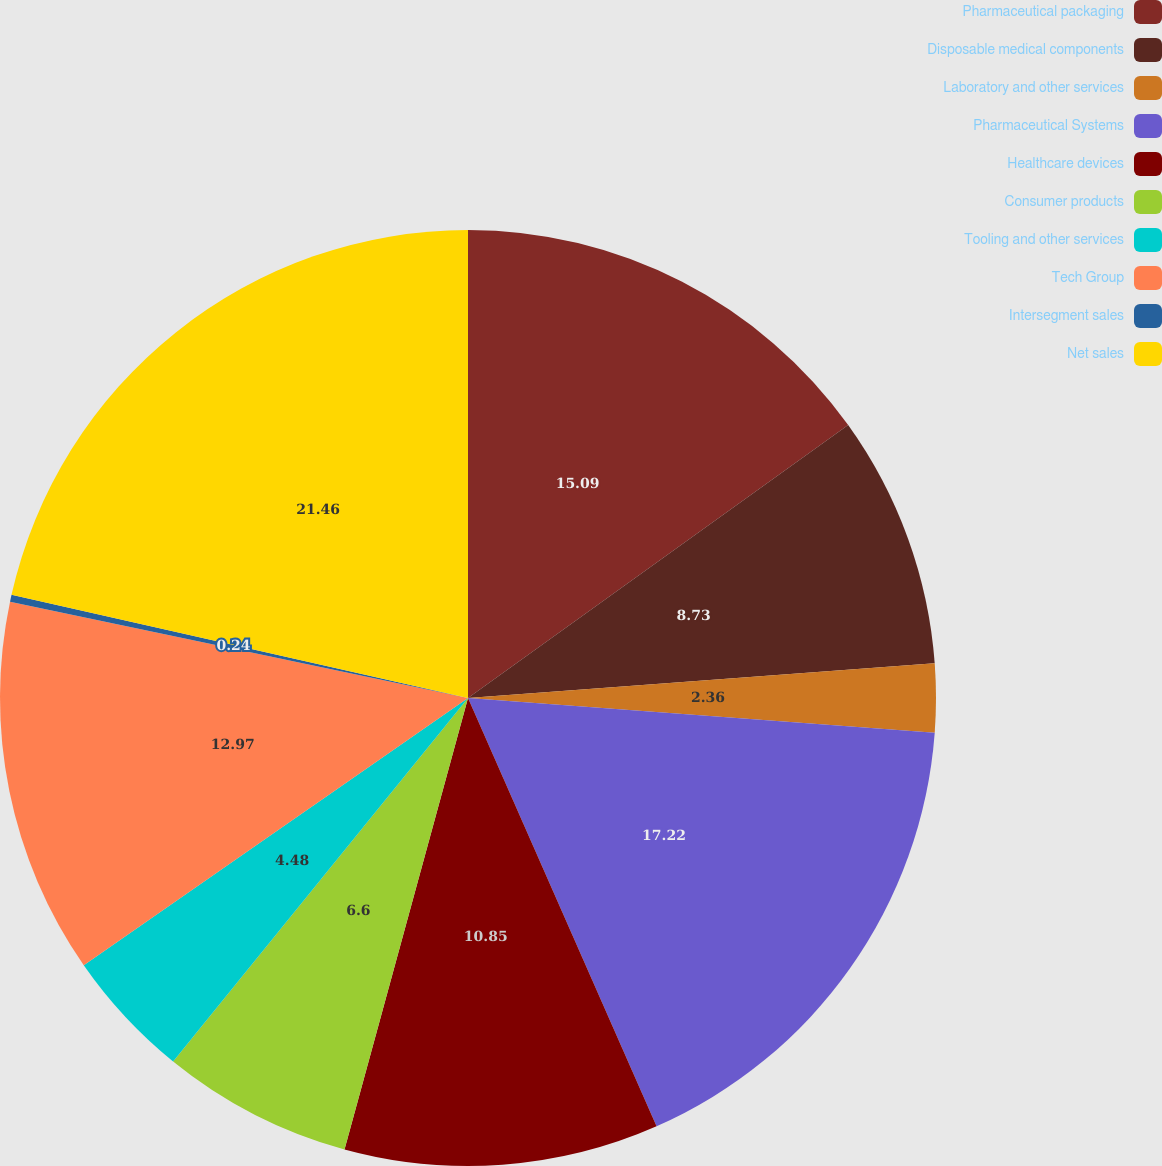Convert chart. <chart><loc_0><loc_0><loc_500><loc_500><pie_chart><fcel>Pharmaceutical packaging<fcel>Disposable medical components<fcel>Laboratory and other services<fcel>Pharmaceutical Systems<fcel>Healthcare devices<fcel>Consumer products<fcel>Tooling and other services<fcel>Tech Group<fcel>Intersegment sales<fcel>Net sales<nl><fcel>15.09%<fcel>8.73%<fcel>2.36%<fcel>17.22%<fcel>10.85%<fcel>6.6%<fcel>4.48%<fcel>12.97%<fcel>0.24%<fcel>21.46%<nl></chart> 